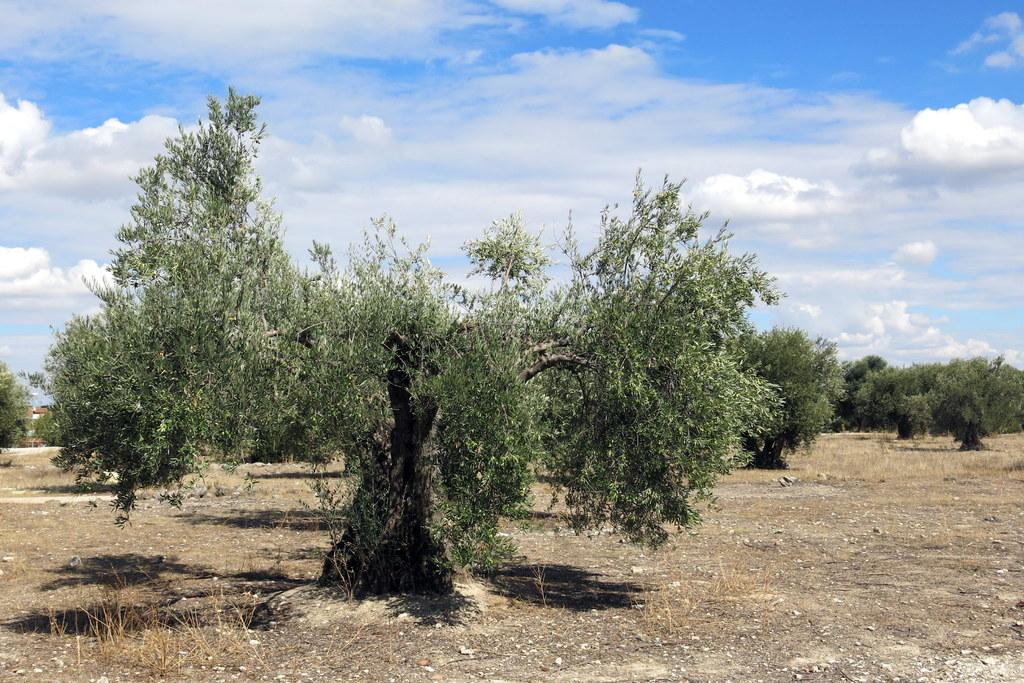What type of vegetation can be seen in the image? There are trees in the image. Where are the trees located? The trees are in an open ground. How many cherries are hanging from the trees in the image? There is no mention of cherries in the image, so we cannot determine the number of cherries present. 